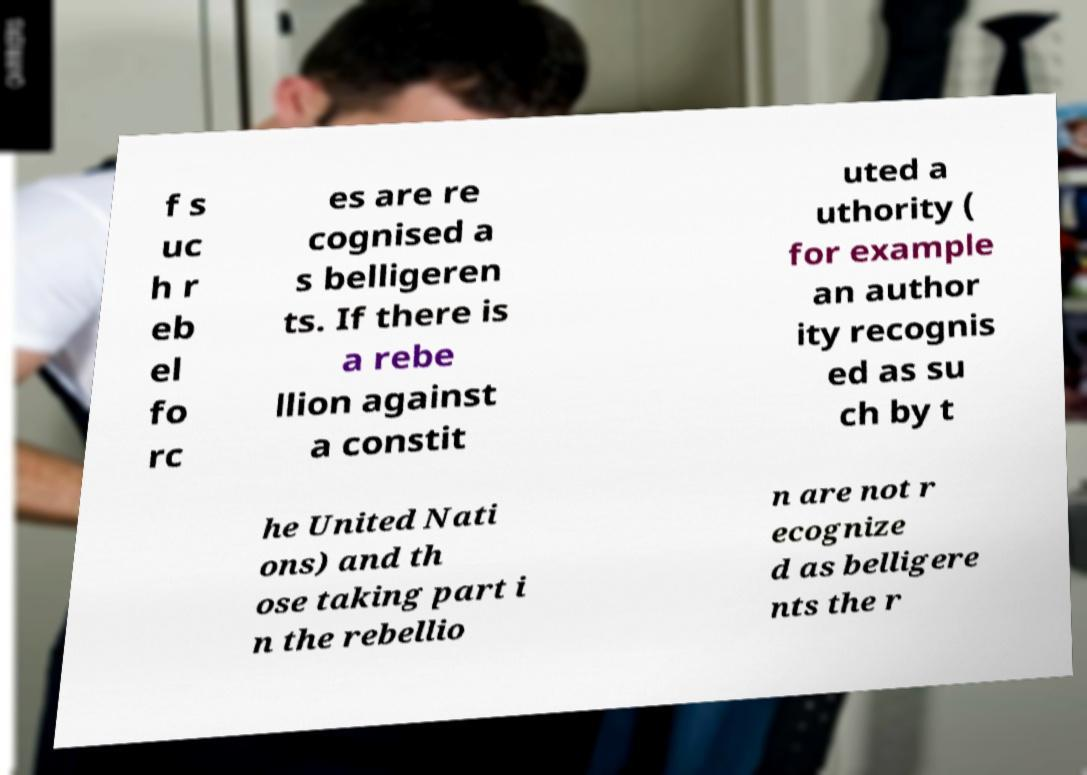For documentation purposes, I need the text within this image transcribed. Could you provide that? f s uc h r eb el fo rc es are re cognised a s belligeren ts. If there is a rebe llion against a constit uted a uthority ( for example an author ity recognis ed as su ch by t he United Nati ons) and th ose taking part i n the rebellio n are not r ecognize d as belligere nts the r 